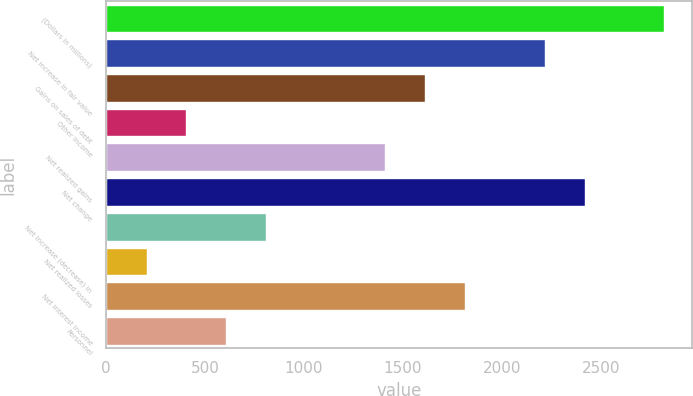Convert chart to OTSL. <chart><loc_0><loc_0><loc_500><loc_500><bar_chart><fcel>(Dollars in millions)<fcel>Net increase in fair value<fcel>Gains on sales of debt<fcel>Other income<fcel>Net realized gains<fcel>Net change<fcel>Net increase (decrease) in<fcel>Net realized losses<fcel>Net interest income<fcel>Personnel<nl><fcel>2821.2<fcel>2217.3<fcel>1613.4<fcel>405.6<fcel>1412.1<fcel>2418.6<fcel>808.2<fcel>204.3<fcel>1814.7<fcel>606.9<nl></chart> 